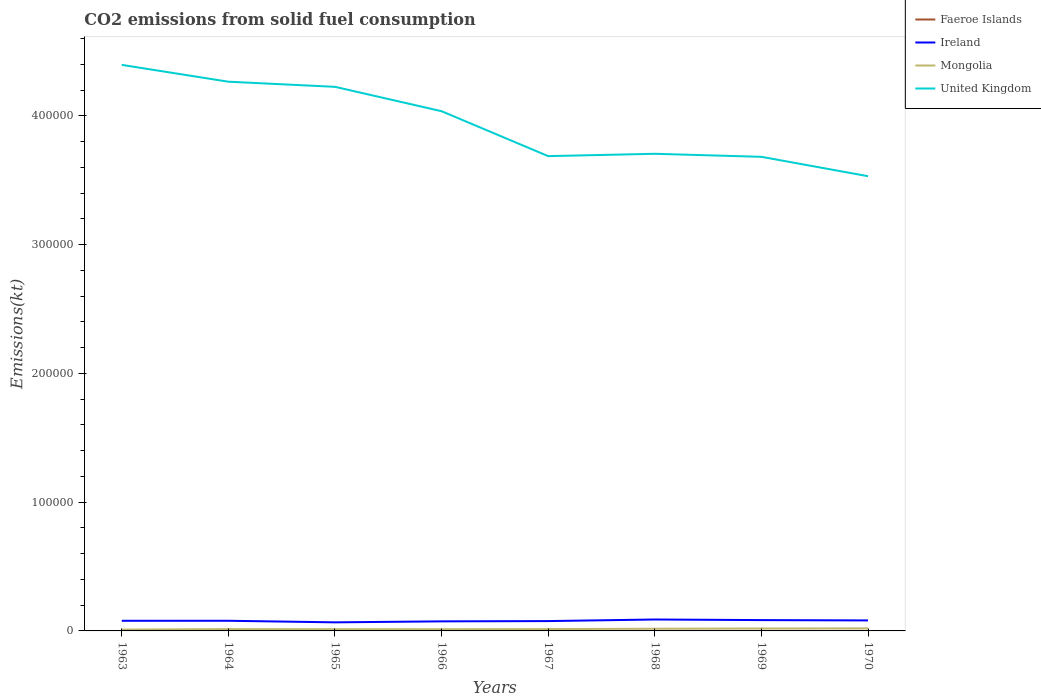Does the line corresponding to Faeroe Islands intersect with the line corresponding to Ireland?
Give a very brief answer. No. Is the number of lines equal to the number of legend labels?
Ensure brevity in your answer.  Yes. Across all years, what is the maximum amount of CO2 emitted in United Kingdom?
Your answer should be very brief. 3.53e+05. What is the total amount of CO2 emitted in United Kingdom in the graph?
Give a very brief answer. 5.20e+04. What is the difference between the highest and the second highest amount of CO2 emitted in Mongolia?
Provide a succinct answer. 953.42. Is the amount of CO2 emitted in Ireland strictly greater than the amount of CO2 emitted in Mongolia over the years?
Your answer should be compact. No. How many lines are there?
Offer a very short reply. 4. How many years are there in the graph?
Your answer should be compact. 8. What is the difference between two consecutive major ticks on the Y-axis?
Keep it short and to the point. 1.00e+05. Does the graph contain grids?
Keep it short and to the point. No. Where does the legend appear in the graph?
Offer a very short reply. Top right. How are the legend labels stacked?
Provide a succinct answer. Vertical. What is the title of the graph?
Give a very brief answer. CO2 emissions from solid fuel consumption. What is the label or title of the Y-axis?
Give a very brief answer. Emissions(kt). What is the Emissions(kt) of Faeroe Islands in 1963?
Ensure brevity in your answer.  11. What is the Emissions(kt) of Ireland in 1963?
Your answer should be compact. 7880.38. What is the Emissions(kt) of Mongolia in 1963?
Give a very brief answer. 1026.76. What is the Emissions(kt) of United Kingdom in 1963?
Your answer should be compact. 4.40e+05. What is the Emissions(kt) in Faeroe Islands in 1964?
Your response must be concise. 7.33. What is the Emissions(kt) of Ireland in 1964?
Provide a succinct answer. 7887.72. What is the Emissions(kt) in Mongolia in 1964?
Provide a succinct answer. 1411.8. What is the Emissions(kt) of United Kingdom in 1964?
Keep it short and to the point. 4.27e+05. What is the Emissions(kt) in Faeroe Islands in 1965?
Your answer should be very brief. 7.33. What is the Emissions(kt) of Ireland in 1965?
Make the answer very short. 6666.61. What is the Emissions(kt) in Mongolia in 1965?
Provide a short and direct response. 1342.12. What is the Emissions(kt) in United Kingdom in 1965?
Offer a very short reply. 4.23e+05. What is the Emissions(kt) in Faeroe Islands in 1966?
Provide a succinct answer. 7.33. What is the Emissions(kt) of Ireland in 1966?
Ensure brevity in your answer.  7425.68. What is the Emissions(kt) in Mongolia in 1966?
Make the answer very short. 1338.45. What is the Emissions(kt) of United Kingdom in 1966?
Offer a terse response. 4.04e+05. What is the Emissions(kt) in Faeroe Islands in 1967?
Offer a very short reply. 3.67. What is the Emissions(kt) of Ireland in 1967?
Make the answer very short. 7649.36. What is the Emissions(kt) of Mongolia in 1967?
Give a very brief answer. 1437.46. What is the Emissions(kt) of United Kingdom in 1967?
Keep it short and to the point. 3.69e+05. What is the Emissions(kt) of Faeroe Islands in 1968?
Give a very brief answer. 3.67. What is the Emissions(kt) in Ireland in 1968?
Provide a short and direct response. 8870.47. What is the Emissions(kt) in Mongolia in 1968?
Ensure brevity in your answer.  1701.49. What is the Emissions(kt) of United Kingdom in 1968?
Keep it short and to the point. 3.71e+05. What is the Emissions(kt) of Faeroe Islands in 1969?
Offer a very short reply. 3.67. What is the Emissions(kt) of Ireland in 1969?
Your answer should be very brief. 8412.1. What is the Emissions(kt) in Mongolia in 1969?
Give a very brief answer. 1877.5. What is the Emissions(kt) of United Kingdom in 1969?
Your answer should be very brief. 3.68e+05. What is the Emissions(kt) in Faeroe Islands in 1970?
Make the answer very short. 3.67. What is the Emissions(kt) in Ireland in 1970?
Offer a very short reply. 8155.41. What is the Emissions(kt) in Mongolia in 1970?
Your response must be concise. 1980.18. What is the Emissions(kt) of United Kingdom in 1970?
Offer a terse response. 3.53e+05. Across all years, what is the maximum Emissions(kt) of Faeroe Islands?
Offer a terse response. 11. Across all years, what is the maximum Emissions(kt) of Ireland?
Keep it short and to the point. 8870.47. Across all years, what is the maximum Emissions(kt) of Mongolia?
Your answer should be compact. 1980.18. Across all years, what is the maximum Emissions(kt) of United Kingdom?
Your response must be concise. 4.40e+05. Across all years, what is the minimum Emissions(kt) of Faeroe Islands?
Offer a very short reply. 3.67. Across all years, what is the minimum Emissions(kt) in Ireland?
Your answer should be compact. 6666.61. Across all years, what is the minimum Emissions(kt) of Mongolia?
Offer a very short reply. 1026.76. Across all years, what is the minimum Emissions(kt) in United Kingdom?
Give a very brief answer. 3.53e+05. What is the total Emissions(kt) in Faeroe Islands in the graph?
Provide a short and direct response. 47.67. What is the total Emissions(kt) in Ireland in the graph?
Make the answer very short. 6.29e+04. What is the total Emissions(kt) of Mongolia in the graph?
Your response must be concise. 1.21e+04. What is the total Emissions(kt) of United Kingdom in the graph?
Make the answer very short. 3.15e+06. What is the difference between the Emissions(kt) in Faeroe Islands in 1963 and that in 1964?
Give a very brief answer. 3.67. What is the difference between the Emissions(kt) of Ireland in 1963 and that in 1964?
Provide a succinct answer. -7.33. What is the difference between the Emissions(kt) in Mongolia in 1963 and that in 1964?
Keep it short and to the point. -385.04. What is the difference between the Emissions(kt) in United Kingdom in 1963 and that in 1964?
Your answer should be compact. 1.31e+04. What is the difference between the Emissions(kt) of Faeroe Islands in 1963 and that in 1965?
Make the answer very short. 3.67. What is the difference between the Emissions(kt) of Ireland in 1963 and that in 1965?
Keep it short and to the point. 1213.78. What is the difference between the Emissions(kt) in Mongolia in 1963 and that in 1965?
Ensure brevity in your answer.  -315.36. What is the difference between the Emissions(kt) of United Kingdom in 1963 and that in 1965?
Your answer should be very brief. 1.70e+04. What is the difference between the Emissions(kt) in Faeroe Islands in 1963 and that in 1966?
Your answer should be very brief. 3.67. What is the difference between the Emissions(kt) of Ireland in 1963 and that in 1966?
Provide a short and direct response. 454.71. What is the difference between the Emissions(kt) of Mongolia in 1963 and that in 1966?
Ensure brevity in your answer.  -311.69. What is the difference between the Emissions(kt) of United Kingdom in 1963 and that in 1966?
Provide a short and direct response. 3.60e+04. What is the difference between the Emissions(kt) in Faeroe Islands in 1963 and that in 1967?
Provide a short and direct response. 7.33. What is the difference between the Emissions(kt) of Ireland in 1963 and that in 1967?
Offer a terse response. 231.02. What is the difference between the Emissions(kt) in Mongolia in 1963 and that in 1967?
Offer a very short reply. -410.7. What is the difference between the Emissions(kt) in United Kingdom in 1963 and that in 1967?
Give a very brief answer. 7.09e+04. What is the difference between the Emissions(kt) of Faeroe Islands in 1963 and that in 1968?
Make the answer very short. 7.33. What is the difference between the Emissions(kt) in Ireland in 1963 and that in 1968?
Make the answer very short. -990.09. What is the difference between the Emissions(kt) in Mongolia in 1963 and that in 1968?
Your response must be concise. -674.73. What is the difference between the Emissions(kt) of United Kingdom in 1963 and that in 1968?
Your answer should be very brief. 6.91e+04. What is the difference between the Emissions(kt) of Faeroe Islands in 1963 and that in 1969?
Provide a succinct answer. 7.33. What is the difference between the Emissions(kt) of Ireland in 1963 and that in 1969?
Make the answer very short. -531.72. What is the difference between the Emissions(kt) in Mongolia in 1963 and that in 1969?
Offer a terse response. -850.74. What is the difference between the Emissions(kt) of United Kingdom in 1963 and that in 1969?
Offer a terse response. 7.14e+04. What is the difference between the Emissions(kt) in Faeroe Islands in 1963 and that in 1970?
Your answer should be compact. 7.33. What is the difference between the Emissions(kt) of Ireland in 1963 and that in 1970?
Offer a terse response. -275.02. What is the difference between the Emissions(kt) of Mongolia in 1963 and that in 1970?
Provide a succinct answer. -953.42. What is the difference between the Emissions(kt) of United Kingdom in 1963 and that in 1970?
Your response must be concise. 8.65e+04. What is the difference between the Emissions(kt) of Faeroe Islands in 1964 and that in 1965?
Offer a very short reply. 0. What is the difference between the Emissions(kt) of Ireland in 1964 and that in 1965?
Offer a terse response. 1221.11. What is the difference between the Emissions(kt) of Mongolia in 1964 and that in 1965?
Give a very brief answer. 69.67. What is the difference between the Emissions(kt) in United Kingdom in 1964 and that in 1965?
Your answer should be compact. 3975.03. What is the difference between the Emissions(kt) in Ireland in 1964 and that in 1966?
Keep it short and to the point. 462.04. What is the difference between the Emissions(kt) of Mongolia in 1964 and that in 1966?
Offer a very short reply. 73.34. What is the difference between the Emissions(kt) in United Kingdom in 1964 and that in 1966?
Make the answer very short. 2.29e+04. What is the difference between the Emissions(kt) of Faeroe Islands in 1964 and that in 1967?
Offer a terse response. 3.67. What is the difference between the Emissions(kt) of Ireland in 1964 and that in 1967?
Make the answer very short. 238.35. What is the difference between the Emissions(kt) of Mongolia in 1964 and that in 1967?
Your answer should be very brief. -25.67. What is the difference between the Emissions(kt) of United Kingdom in 1964 and that in 1967?
Give a very brief answer. 5.78e+04. What is the difference between the Emissions(kt) of Faeroe Islands in 1964 and that in 1968?
Offer a very short reply. 3.67. What is the difference between the Emissions(kt) of Ireland in 1964 and that in 1968?
Provide a succinct answer. -982.76. What is the difference between the Emissions(kt) of Mongolia in 1964 and that in 1968?
Provide a succinct answer. -289.69. What is the difference between the Emissions(kt) in United Kingdom in 1964 and that in 1968?
Your response must be concise. 5.60e+04. What is the difference between the Emissions(kt) of Faeroe Islands in 1964 and that in 1969?
Your answer should be very brief. 3.67. What is the difference between the Emissions(kt) of Ireland in 1964 and that in 1969?
Give a very brief answer. -524.38. What is the difference between the Emissions(kt) of Mongolia in 1964 and that in 1969?
Offer a very short reply. -465.71. What is the difference between the Emissions(kt) of United Kingdom in 1964 and that in 1969?
Provide a short and direct response. 5.83e+04. What is the difference between the Emissions(kt) of Faeroe Islands in 1964 and that in 1970?
Provide a short and direct response. 3.67. What is the difference between the Emissions(kt) of Ireland in 1964 and that in 1970?
Offer a very short reply. -267.69. What is the difference between the Emissions(kt) in Mongolia in 1964 and that in 1970?
Ensure brevity in your answer.  -568.38. What is the difference between the Emissions(kt) in United Kingdom in 1964 and that in 1970?
Make the answer very short. 7.34e+04. What is the difference between the Emissions(kt) in Ireland in 1965 and that in 1966?
Provide a short and direct response. -759.07. What is the difference between the Emissions(kt) in Mongolia in 1965 and that in 1966?
Offer a very short reply. 3.67. What is the difference between the Emissions(kt) in United Kingdom in 1965 and that in 1966?
Ensure brevity in your answer.  1.89e+04. What is the difference between the Emissions(kt) in Faeroe Islands in 1965 and that in 1967?
Offer a terse response. 3.67. What is the difference between the Emissions(kt) in Ireland in 1965 and that in 1967?
Offer a terse response. -982.76. What is the difference between the Emissions(kt) of Mongolia in 1965 and that in 1967?
Your answer should be very brief. -95.34. What is the difference between the Emissions(kt) in United Kingdom in 1965 and that in 1967?
Your response must be concise. 5.38e+04. What is the difference between the Emissions(kt) in Faeroe Islands in 1965 and that in 1968?
Ensure brevity in your answer.  3.67. What is the difference between the Emissions(kt) in Ireland in 1965 and that in 1968?
Offer a terse response. -2203.87. What is the difference between the Emissions(kt) in Mongolia in 1965 and that in 1968?
Offer a terse response. -359.37. What is the difference between the Emissions(kt) in United Kingdom in 1965 and that in 1968?
Keep it short and to the point. 5.20e+04. What is the difference between the Emissions(kt) of Faeroe Islands in 1965 and that in 1969?
Provide a succinct answer. 3.67. What is the difference between the Emissions(kt) in Ireland in 1965 and that in 1969?
Make the answer very short. -1745.49. What is the difference between the Emissions(kt) of Mongolia in 1965 and that in 1969?
Your response must be concise. -535.38. What is the difference between the Emissions(kt) in United Kingdom in 1965 and that in 1969?
Offer a very short reply. 5.44e+04. What is the difference between the Emissions(kt) in Faeroe Islands in 1965 and that in 1970?
Keep it short and to the point. 3.67. What is the difference between the Emissions(kt) in Ireland in 1965 and that in 1970?
Your answer should be compact. -1488.8. What is the difference between the Emissions(kt) in Mongolia in 1965 and that in 1970?
Provide a succinct answer. -638.06. What is the difference between the Emissions(kt) in United Kingdom in 1965 and that in 1970?
Make the answer very short. 6.94e+04. What is the difference between the Emissions(kt) in Faeroe Islands in 1966 and that in 1967?
Keep it short and to the point. 3.67. What is the difference between the Emissions(kt) of Ireland in 1966 and that in 1967?
Your answer should be compact. -223.69. What is the difference between the Emissions(kt) in Mongolia in 1966 and that in 1967?
Make the answer very short. -99.01. What is the difference between the Emissions(kt) of United Kingdom in 1966 and that in 1967?
Your answer should be very brief. 3.49e+04. What is the difference between the Emissions(kt) of Faeroe Islands in 1966 and that in 1968?
Offer a very short reply. 3.67. What is the difference between the Emissions(kt) of Ireland in 1966 and that in 1968?
Offer a very short reply. -1444.8. What is the difference between the Emissions(kt) of Mongolia in 1966 and that in 1968?
Give a very brief answer. -363.03. What is the difference between the Emissions(kt) of United Kingdom in 1966 and that in 1968?
Your response must be concise. 3.31e+04. What is the difference between the Emissions(kt) of Faeroe Islands in 1966 and that in 1969?
Make the answer very short. 3.67. What is the difference between the Emissions(kt) in Ireland in 1966 and that in 1969?
Offer a terse response. -986.42. What is the difference between the Emissions(kt) in Mongolia in 1966 and that in 1969?
Make the answer very short. -539.05. What is the difference between the Emissions(kt) of United Kingdom in 1966 and that in 1969?
Provide a succinct answer. 3.54e+04. What is the difference between the Emissions(kt) in Faeroe Islands in 1966 and that in 1970?
Ensure brevity in your answer.  3.67. What is the difference between the Emissions(kt) of Ireland in 1966 and that in 1970?
Give a very brief answer. -729.73. What is the difference between the Emissions(kt) in Mongolia in 1966 and that in 1970?
Make the answer very short. -641.73. What is the difference between the Emissions(kt) in United Kingdom in 1966 and that in 1970?
Offer a terse response. 5.05e+04. What is the difference between the Emissions(kt) in Ireland in 1967 and that in 1968?
Your answer should be compact. -1221.11. What is the difference between the Emissions(kt) of Mongolia in 1967 and that in 1968?
Ensure brevity in your answer.  -264.02. What is the difference between the Emissions(kt) in United Kingdom in 1967 and that in 1968?
Offer a very short reply. -1818.83. What is the difference between the Emissions(kt) in Ireland in 1967 and that in 1969?
Provide a succinct answer. -762.74. What is the difference between the Emissions(kt) of Mongolia in 1967 and that in 1969?
Make the answer very short. -440.04. What is the difference between the Emissions(kt) in United Kingdom in 1967 and that in 1969?
Keep it short and to the point. 535.38. What is the difference between the Emissions(kt) in Ireland in 1967 and that in 1970?
Your answer should be compact. -506.05. What is the difference between the Emissions(kt) in Mongolia in 1967 and that in 1970?
Your response must be concise. -542.72. What is the difference between the Emissions(kt) in United Kingdom in 1967 and that in 1970?
Give a very brief answer. 1.56e+04. What is the difference between the Emissions(kt) of Faeroe Islands in 1968 and that in 1969?
Make the answer very short. 0. What is the difference between the Emissions(kt) of Ireland in 1968 and that in 1969?
Keep it short and to the point. 458.38. What is the difference between the Emissions(kt) of Mongolia in 1968 and that in 1969?
Make the answer very short. -176.02. What is the difference between the Emissions(kt) in United Kingdom in 1968 and that in 1969?
Offer a terse response. 2354.21. What is the difference between the Emissions(kt) in Faeroe Islands in 1968 and that in 1970?
Give a very brief answer. 0. What is the difference between the Emissions(kt) of Ireland in 1968 and that in 1970?
Make the answer very short. 715.07. What is the difference between the Emissions(kt) of Mongolia in 1968 and that in 1970?
Ensure brevity in your answer.  -278.69. What is the difference between the Emissions(kt) in United Kingdom in 1968 and that in 1970?
Your answer should be very brief. 1.74e+04. What is the difference between the Emissions(kt) of Faeroe Islands in 1969 and that in 1970?
Your answer should be very brief. 0. What is the difference between the Emissions(kt) in Ireland in 1969 and that in 1970?
Offer a very short reply. 256.69. What is the difference between the Emissions(kt) of Mongolia in 1969 and that in 1970?
Ensure brevity in your answer.  -102.68. What is the difference between the Emissions(kt) in United Kingdom in 1969 and that in 1970?
Give a very brief answer. 1.51e+04. What is the difference between the Emissions(kt) in Faeroe Islands in 1963 and the Emissions(kt) in Ireland in 1964?
Make the answer very short. -7876.72. What is the difference between the Emissions(kt) of Faeroe Islands in 1963 and the Emissions(kt) of Mongolia in 1964?
Make the answer very short. -1400.79. What is the difference between the Emissions(kt) in Faeroe Islands in 1963 and the Emissions(kt) in United Kingdom in 1964?
Ensure brevity in your answer.  -4.27e+05. What is the difference between the Emissions(kt) in Ireland in 1963 and the Emissions(kt) in Mongolia in 1964?
Your answer should be compact. 6468.59. What is the difference between the Emissions(kt) in Ireland in 1963 and the Emissions(kt) in United Kingdom in 1964?
Provide a short and direct response. -4.19e+05. What is the difference between the Emissions(kt) in Mongolia in 1963 and the Emissions(kt) in United Kingdom in 1964?
Your answer should be very brief. -4.26e+05. What is the difference between the Emissions(kt) of Faeroe Islands in 1963 and the Emissions(kt) of Ireland in 1965?
Offer a very short reply. -6655.6. What is the difference between the Emissions(kt) in Faeroe Islands in 1963 and the Emissions(kt) in Mongolia in 1965?
Your response must be concise. -1331.12. What is the difference between the Emissions(kt) in Faeroe Islands in 1963 and the Emissions(kt) in United Kingdom in 1965?
Make the answer very short. -4.23e+05. What is the difference between the Emissions(kt) in Ireland in 1963 and the Emissions(kt) in Mongolia in 1965?
Offer a terse response. 6538.26. What is the difference between the Emissions(kt) in Ireland in 1963 and the Emissions(kt) in United Kingdom in 1965?
Keep it short and to the point. -4.15e+05. What is the difference between the Emissions(kt) of Mongolia in 1963 and the Emissions(kt) of United Kingdom in 1965?
Offer a terse response. -4.22e+05. What is the difference between the Emissions(kt) of Faeroe Islands in 1963 and the Emissions(kt) of Ireland in 1966?
Keep it short and to the point. -7414.67. What is the difference between the Emissions(kt) of Faeroe Islands in 1963 and the Emissions(kt) of Mongolia in 1966?
Make the answer very short. -1327.45. What is the difference between the Emissions(kt) of Faeroe Islands in 1963 and the Emissions(kt) of United Kingdom in 1966?
Give a very brief answer. -4.04e+05. What is the difference between the Emissions(kt) in Ireland in 1963 and the Emissions(kt) in Mongolia in 1966?
Offer a very short reply. 6541.93. What is the difference between the Emissions(kt) in Ireland in 1963 and the Emissions(kt) in United Kingdom in 1966?
Offer a very short reply. -3.96e+05. What is the difference between the Emissions(kt) in Mongolia in 1963 and the Emissions(kt) in United Kingdom in 1966?
Your answer should be compact. -4.03e+05. What is the difference between the Emissions(kt) in Faeroe Islands in 1963 and the Emissions(kt) in Ireland in 1967?
Ensure brevity in your answer.  -7638.36. What is the difference between the Emissions(kt) of Faeroe Islands in 1963 and the Emissions(kt) of Mongolia in 1967?
Your answer should be very brief. -1426.46. What is the difference between the Emissions(kt) in Faeroe Islands in 1963 and the Emissions(kt) in United Kingdom in 1967?
Provide a succinct answer. -3.69e+05. What is the difference between the Emissions(kt) of Ireland in 1963 and the Emissions(kt) of Mongolia in 1967?
Offer a terse response. 6442.92. What is the difference between the Emissions(kt) in Ireland in 1963 and the Emissions(kt) in United Kingdom in 1967?
Ensure brevity in your answer.  -3.61e+05. What is the difference between the Emissions(kt) in Mongolia in 1963 and the Emissions(kt) in United Kingdom in 1967?
Your answer should be compact. -3.68e+05. What is the difference between the Emissions(kt) in Faeroe Islands in 1963 and the Emissions(kt) in Ireland in 1968?
Keep it short and to the point. -8859.47. What is the difference between the Emissions(kt) of Faeroe Islands in 1963 and the Emissions(kt) of Mongolia in 1968?
Ensure brevity in your answer.  -1690.49. What is the difference between the Emissions(kt) of Faeroe Islands in 1963 and the Emissions(kt) of United Kingdom in 1968?
Give a very brief answer. -3.71e+05. What is the difference between the Emissions(kt) of Ireland in 1963 and the Emissions(kt) of Mongolia in 1968?
Your answer should be very brief. 6178.9. What is the difference between the Emissions(kt) in Ireland in 1963 and the Emissions(kt) in United Kingdom in 1968?
Your answer should be very brief. -3.63e+05. What is the difference between the Emissions(kt) of Mongolia in 1963 and the Emissions(kt) of United Kingdom in 1968?
Keep it short and to the point. -3.70e+05. What is the difference between the Emissions(kt) of Faeroe Islands in 1963 and the Emissions(kt) of Ireland in 1969?
Offer a very short reply. -8401.1. What is the difference between the Emissions(kt) in Faeroe Islands in 1963 and the Emissions(kt) in Mongolia in 1969?
Ensure brevity in your answer.  -1866.5. What is the difference between the Emissions(kt) of Faeroe Islands in 1963 and the Emissions(kt) of United Kingdom in 1969?
Provide a succinct answer. -3.68e+05. What is the difference between the Emissions(kt) of Ireland in 1963 and the Emissions(kt) of Mongolia in 1969?
Your answer should be very brief. 6002.88. What is the difference between the Emissions(kt) of Ireland in 1963 and the Emissions(kt) of United Kingdom in 1969?
Offer a very short reply. -3.60e+05. What is the difference between the Emissions(kt) of Mongolia in 1963 and the Emissions(kt) of United Kingdom in 1969?
Make the answer very short. -3.67e+05. What is the difference between the Emissions(kt) of Faeroe Islands in 1963 and the Emissions(kt) of Ireland in 1970?
Your response must be concise. -8144.41. What is the difference between the Emissions(kt) of Faeroe Islands in 1963 and the Emissions(kt) of Mongolia in 1970?
Your answer should be very brief. -1969.18. What is the difference between the Emissions(kt) of Faeroe Islands in 1963 and the Emissions(kt) of United Kingdom in 1970?
Your answer should be compact. -3.53e+05. What is the difference between the Emissions(kt) of Ireland in 1963 and the Emissions(kt) of Mongolia in 1970?
Ensure brevity in your answer.  5900.2. What is the difference between the Emissions(kt) of Ireland in 1963 and the Emissions(kt) of United Kingdom in 1970?
Your answer should be compact. -3.45e+05. What is the difference between the Emissions(kt) in Mongolia in 1963 and the Emissions(kt) in United Kingdom in 1970?
Give a very brief answer. -3.52e+05. What is the difference between the Emissions(kt) of Faeroe Islands in 1964 and the Emissions(kt) of Ireland in 1965?
Your response must be concise. -6659.27. What is the difference between the Emissions(kt) of Faeroe Islands in 1964 and the Emissions(kt) of Mongolia in 1965?
Make the answer very short. -1334.79. What is the difference between the Emissions(kt) of Faeroe Islands in 1964 and the Emissions(kt) of United Kingdom in 1965?
Offer a terse response. -4.23e+05. What is the difference between the Emissions(kt) of Ireland in 1964 and the Emissions(kt) of Mongolia in 1965?
Your answer should be very brief. 6545.6. What is the difference between the Emissions(kt) in Ireland in 1964 and the Emissions(kt) in United Kingdom in 1965?
Give a very brief answer. -4.15e+05. What is the difference between the Emissions(kt) in Mongolia in 1964 and the Emissions(kt) in United Kingdom in 1965?
Make the answer very short. -4.21e+05. What is the difference between the Emissions(kt) of Faeroe Islands in 1964 and the Emissions(kt) of Ireland in 1966?
Give a very brief answer. -7418.34. What is the difference between the Emissions(kt) in Faeroe Islands in 1964 and the Emissions(kt) in Mongolia in 1966?
Make the answer very short. -1331.12. What is the difference between the Emissions(kt) in Faeroe Islands in 1964 and the Emissions(kt) in United Kingdom in 1966?
Give a very brief answer. -4.04e+05. What is the difference between the Emissions(kt) in Ireland in 1964 and the Emissions(kt) in Mongolia in 1966?
Offer a very short reply. 6549.26. What is the difference between the Emissions(kt) of Ireland in 1964 and the Emissions(kt) of United Kingdom in 1966?
Offer a very short reply. -3.96e+05. What is the difference between the Emissions(kt) of Mongolia in 1964 and the Emissions(kt) of United Kingdom in 1966?
Make the answer very short. -4.02e+05. What is the difference between the Emissions(kt) of Faeroe Islands in 1964 and the Emissions(kt) of Ireland in 1967?
Give a very brief answer. -7642.03. What is the difference between the Emissions(kt) of Faeroe Islands in 1964 and the Emissions(kt) of Mongolia in 1967?
Offer a very short reply. -1430.13. What is the difference between the Emissions(kt) of Faeroe Islands in 1964 and the Emissions(kt) of United Kingdom in 1967?
Your answer should be compact. -3.69e+05. What is the difference between the Emissions(kt) of Ireland in 1964 and the Emissions(kt) of Mongolia in 1967?
Your response must be concise. 6450.25. What is the difference between the Emissions(kt) in Ireland in 1964 and the Emissions(kt) in United Kingdom in 1967?
Keep it short and to the point. -3.61e+05. What is the difference between the Emissions(kt) of Mongolia in 1964 and the Emissions(kt) of United Kingdom in 1967?
Provide a short and direct response. -3.67e+05. What is the difference between the Emissions(kt) of Faeroe Islands in 1964 and the Emissions(kt) of Ireland in 1968?
Your response must be concise. -8863.14. What is the difference between the Emissions(kt) in Faeroe Islands in 1964 and the Emissions(kt) in Mongolia in 1968?
Your response must be concise. -1694.15. What is the difference between the Emissions(kt) in Faeroe Islands in 1964 and the Emissions(kt) in United Kingdom in 1968?
Ensure brevity in your answer.  -3.71e+05. What is the difference between the Emissions(kt) in Ireland in 1964 and the Emissions(kt) in Mongolia in 1968?
Your answer should be compact. 6186.23. What is the difference between the Emissions(kt) of Ireland in 1964 and the Emissions(kt) of United Kingdom in 1968?
Offer a terse response. -3.63e+05. What is the difference between the Emissions(kt) of Mongolia in 1964 and the Emissions(kt) of United Kingdom in 1968?
Your response must be concise. -3.69e+05. What is the difference between the Emissions(kt) in Faeroe Islands in 1964 and the Emissions(kt) in Ireland in 1969?
Ensure brevity in your answer.  -8404.76. What is the difference between the Emissions(kt) of Faeroe Islands in 1964 and the Emissions(kt) of Mongolia in 1969?
Give a very brief answer. -1870.17. What is the difference between the Emissions(kt) of Faeroe Islands in 1964 and the Emissions(kt) of United Kingdom in 1969?
Your answer should be compact. -3.68e+05. What is the difference between the Emissions(kt) in Ireland in 1964 and the Emissions(kt) in Mongolia in 1969?
Your answer should be compact. 6010.21. What is the difference between the Emissions(kt) of Ireland in 1964 and the Emissions(kt) of United Kingdom in 1969?
Your answer should be compact. -3.60e+05. What is the difference between the Emissions(kt) in Mongolia in 1964 and the Emissions(kt) in United Kingdom in 1969?
Give a very brief answer. -3.67e+05. What is the difference between the Emissions(kt) in Faeroe Islands in 1964 and the Emissions(kt) in Ireland in 1970?
Ensure brevity in your answer.  -8148.07. What is the difference between the Emissions(kt) of Faeroe Islands in 1964 and the Emissions(kt) of Mongolia in 1970?
Offer a terse response. -1972.85. What is the difference between the Emissions(kt) in Faeroe Islands in 1964 and the Emissions(kt) in United Kingdom in 1970?
Your response must be concise. -3.53e+05. What is the difference between the Emissions(kt) of Ireland in 1964 and the Emissions(kt) of Mongolia in 1970?
Make the answer very short. 5907.54. What is the difference between the Emissions(kt) of Ireland in 1964 and the Emissions(kt) of United Kingdom in 1970?
Your answer should be compact. -3.45e+05. What is the difference between the Emissions(kt) in Mongolia in 1964 and the Emissions(kt) in United Kingdom in 1970?
Make the answer very short. -3.52e+05. What is the difference between the Emissions(kt) in Faeroe Islands in 1965 and the Emissions(kt) in Ireland in 1966?
Offer a terse response. -7418.34. What is the difference between the Emissions(kt) of Faeroe Islands in 1965 and the Emissions(kt) of Mongolia in 1966?
Provide a short and direct response. -1331.12. What is the difference between the Emissions(kt) in Faeroe Islands in 1965 and the Emissions(kt) in United Kingdom in 1966?
Ensure brevity in your answer.  -4.04e+05. What is the difference between the Emissions(kt) in Ireland in 1965 and the Emissions(kt) in Mongolia in 1966?
Your answer should be compact. 5328.15. What is the difference between the Emissions(kt) of Ireland in 1965 and the Emissions(kt) of United Kingdom in 1966?
Offer a very short reply. -3.97e+05. What is the difference between the Emissions(kt) of Mongolia in 1965 and the Emissions(kt) of United Kingdom in 1966?
Offer a very short reply. -4.02e+05. What is the difference between the Emissions(kt) in Faeroe Islands in 1965 and the Emissions(kt) in Ireland in 1967?
Provide a short and direct response. -7642.03. What is the difference between the Emissions(kt) of Faeroe Islands in 1965 and the Emissions(kt) of Mongolia in 1967?
Make the answer very short. -1430.13. What is the difference between the Emissions(kt) of Faeroe Islands in 1965 and the Emissions(kt) of United Kingdom in 1967?
Give a very brief answer. -3.69e+05. What is the difference between the Emissions(kt) of Ireland in 1965 and the Emissions(kt) of Mongolia in 1967?
Give a very brief answer. 5229.14. What is the difference between the Emissions(kt) in Ireland in 1965 and the Emissions(kt) in United Kingdom in 1967?
Provide a succinct answer. -3.62e+05. What is the difference between the Emissions(kt) in Mongolia in 1965 and the Emissions(kt) in United Kingdom in 1967?
Ensure brevity in your answer.  -3.67e+05. What is the difference between the Emissions(kt) in Faeroe Islands in 1965 and the Emissions(kt) in Ireland in 1968?
Provide a succinct answer. -8863.14. What is the difference between the Emissions(kt) in Faeroe Islands in 1965 and the Emissions(kt) in Mongolia in 1968?
Your answer should be compact. -1694.15. What is the difference between the Emissions(kt) in Faeroe Islands in 1965 and the Emissions(kt) in United Kingdom in 1968?
Make the answer very short. -3.71e+05. What is the difference between the Emissions(kt) of Ireland in 1965 and the Emissions(kt) of Mongolia in 1968?
Give a very brief answer. 4965.12. What is the difference between the Emissions(kt) in Ireland in 1965 and the Emissions(kt) in United Kingdom in 1968?
Offer a very short reply. -3.64e+05. What is the difference between the Emissions(kt) in Mongolia in 1965 and the Emissions(kt) in United Kingdom in 1968?
Offer a terse response. -3.69e+05. What is the difference between the Emissions(kt) of Faeroe Islands in 1965 and the Emissions(kt) of Ireland in 1969?
Make the answer very short. -8404.76. What is the difference between the Emissions(kt) of Faeroe Islands in 1965 and the Emissions(kt) of Mongolia in 1969?
Your answer should be compact. -1870.17. What is the difference between the Emissions(kt) of Faeroe Islands in 1965 and the Emissions(kt) of United Kingdom in 1969?
Ensure brevity in your answer.  -3.68e+05. What is the difference between the Emissions(kt) in Ireland in 1965 and the Emissions(kt) in Mongolia in 1969?
Give a very brief answer. 4789.1. What is the difference between the Emissions(kt) in Ireland in 1965 and the Emissions(kt) in United Kingdom in 1969?
Make the answer very short. -3.62e+05. What is the difference between the Emissions(kt) in Mongolia in 1965 and the Emissions(kt) in United Kingdom in 1969?
Give a very brief answer. -3.67e+05. What is the difference between the Emissions(kt) in Faeroe Islands in 1965 and the Emissions(kt) in Ireland in 1970?
Provide a succinct answer. -8148.07. What is the difference between the Emissions(kt) of Faeroe Islands in 1965 and the Emissions(kt) of Mongolia in 1970?
Your response must be concise. -1972.85. What is the difference between the Emissions(kt) of Faeroe Islands in 1965 and the Emissions(kt) of United Kingdom in 1970?
Make the answer very short. -3.53e+05. What is the difference between the Emissions(kt) of Ireland in 1965 and the Emissions(kt) of Mongolia in 1970?
Provide a succinct answer. 4686.43. What is the difference between the Emissions(kt) of Ireland in 1965 and the Emissions(kt) of United Kingdom in 1970?
Make the answer very short. -3.47e+05. What is the difference between the Emissions(kt) in Mongolia in 1965 and the Emissions(kt) in United Kingdom in 1970?
Make the answer very short. -3.52e+05. What is the difference between the Emissions(kt) in Faeroe Islands in 1966 and the Emissions(kt) in Ireland in 1967?
Keep it short and to the point. -7642.03. What is the difference between the Emissions(kt) of Faeroe Islands in 1966 and the Emissions(kt) of Mongolia in 1967?
Provide a short and direct response. -1430.13. What is the difference between the Emissions(kt) in Faeroe Islands in 1966 and the Emissions(kt) in United Kingdom in 1967?
Ensure brevity in your answer.  -3.69e+05. What is the difference between the Emissions(kt) of Ireland in 1966 and the Emissions(kt) of Mongolia in 1967?
Provide a succinct answer. 5988.21. What is the difference between the Emissions(kt) in Ireland in 1966 and the Emissions(kt) in United Kingdom in 1967?
Your answer should be very brief. -3.61e+05. What is the difference between the Emissions(kt) in Mongolia in 1966 and the Emissions(kt) in United Kingdom in 1967?
Your answer should be compact. -3.67e+05. What is the difference between the Emissions(kt) in Faeroe Islands in 1966 and the Emissions(kt) in Ireland in 1968?
Offer a terse response. -8863.14. What is the difference between the Emissions(kt) of Faeroe Islands in 1966 and the Emissions(kt) of Mongolia in 1968?
Your response must be concise. -1694.15. What is the difference between the Emissions(kt) in Faeroe Islands in 1966 and the Emissions(kt) in United Kingdom in 1968?
Give a very brief answer. -3.71e+05. What is the difference between the Emissions(kt) of Ireland in 1966 and the Emissions(kt) of Mongolia in 1968?
Offer a terse response. 5724.19. What is the difference between the Emissions(kt) in Ireland in 1966 and the Emissions(kt) in United Kingdom in 1968?
Provide a short and direct response. -3.63e+05. What is the difference between the Emissions(kt) of Mongolia in 1966 and the Emissions(kt) of United Kingdom in 1968?
Ensure brevity in your answer.  -3.69e+05. What is the difference between the Emissions(kt) of Faeroe Islands in 1966 and the Emissions(kt) of Ireland in 1969?
Give a very brief answer. -8404.76. What is the difference between the Emissions(kt) in Faeroe Islands in 1966 and the Emissions(kt) in Mongolia in 1969?
Provide a succinct answer. -1870.17. What is the difference between the Emissions(kt) of Faeroe Islands in 1966 and the Emissions(kt) of United Kingdom in 1969?
Ensure brevity in your answer.  -3.68e+05. What is the difference between the Emissions(kt) in Ireland in 1966 and the Emissions(kt) in Mongolia in 1969?
Offer a very short reply. 5548.17. What is the difference between the Emissions(kt) in Ireland in 1966 and the Emissions(kt) in United Kingdom in 1969?
Keep it short and to the point. -3.61e+05. What is the difference between the Emissions(kt) in Mongolia in 1966 and the Emissions(kt) in United Kingdom in 1969?
Offer a terse response. -3.67e+05. What is the difference between the Emissions(kt) in Faeroe Islands in 1966 and the Emissions(kt) in Ireland in 1970?
Offer a very short reply. -8148.07. What is the difference between the Emissions(kt) in Faeroe Islands in 1966 and the Emissions(kt) in Mongolia in 1970?
Offer a terse response. -1972.85. What is the difference between the Emissions(kt) of Faeroe Islands in 1966 and the Emissions(kt) of United Kingdom in 1970?
Offer a very short reply. -3.53e+05. What is the difference between the Emissions(kt) of Ireland in 1966 and the Emissions(kt) of Mongolia in 1970?
Your answer should be compact. 5445.49. What is the difference between the Emissions(kt) in Ireland in 1966 and the Emissions(kt) in United Kingdom in 1970?
Your response must be concise. -3.46e+05. What is the difference between the Emissions(kt) in Mongolia in 1966 and the Emissions(kt) in United Kingdom in 1970?
Give a very brief answer. -3.52e+05. What is the difference between the Emissions(kt) of Faeroe Islands in 1967 and the Emissions(kt) of Ireland in 1968?
Ensure brevity in your answer.  -8866.81. What is the difference between the Emissions(kt) of Faeroe Islands in 1967 and the Emissions(kt) of Mongolia in 1968?
Offer a very short reply. -1697.82. What is the difference between the Emissions(kt) in Faeroe Islands in 1967 and the Emissions(kt) in United Kingdom in 1968?
Keep it short and to the point. -3.71e+05. What is the difference between the Emissions(kt) of Ireland in 1967 and the Emissions(kt) of Mongolia in 1968?
Your answer should be compact. 5947.87. What is the difference between the Emissions(kt) of Ireland in 1967 and the Emissions(kt) of United Kingdom in 1968?
Provide a succinct answer. -3.63e+05. What is the difference between the Emissions(kt) of Mongolia in 1967 and the Emissions(kt) of United Kingdom in 1968?
Give a very brief answer. -3.69e+05. What is the difference between the Emissions(kt) in Faeroe Islands in 1967 and the Emissions(kt) in Ireland in 1969?
Make the answer very short. -8408.43. What is the difference between the Emissions(kt) in Faeroe Islands in 1967 and the Emissions(kt) in Mongolia in 1969?
Make the answer very short. -1873.84. What is the difference between the Emissions(kt) in Faeroe Islands in 1967 and the Emissions(kt) in United Kingdom in 1969?
Offer a terse response. -3.68e+05. What is the difference between the Emissions(kt) of Ireland in 1967 and the Emissions(kt) of Mongolia in 1969?
Make the answer very short. 5771.86. What is the difference between the Emissions(kt) of Ireland in 1967 and the Emissions(kt) of United Kingdom in 1969?
Provide a short and direct response. -3.61e+05. What is the difference between the Emissions(kt) in Mongolia in 1967 and the Emissions(kt) in United Kingdom in 1969?
Your response must be concise. -3.67e+05. What is the difference between the Emissions(kt) of Faeroe Islands in 1967 and the Emissions(kt) of Ireland in 1970?
Your response must be concise. -8151.74. What is the difference between the Emissions(kt) of Faeroe Islands in 1967 and the Emissions(kt) of Mongolia in 1970?
Make the answer very short. -1976.51. What is the difference between the Emissions(kt) in Faeroe Islands in 1967 and the Emissions(kt) in United Kingdom in 1970?
Give a very brief answer. -3.53e+05. What is the difference between the Emissions(kt) in Ireland in 1967 and the Emissions(kt) in Mongolia in 1970?
Give a very brief answer. 5669.18. What is the difference between the Emissions(kt) of Ireland in 1967 and the Emissions(kt) of United Kingdom in 1970?
Your response must be concise. -3.46e+05. What is the difference between the Emissions(kt) in Mongolia in 1967 and the Emissions(kt) in United Kingdom in 1970?
Provide a short and direct response. -3.52e+05. What is the difference between the Emissions(kt) of Faeroe Islands in 1968 and the Emissions(kt) of Ireland in 1969?
Offer a terse response. -8408.43. What is the difference between the Emissions(kt) in Faeroe Islands in 1968 and the Emissions(kt) in Mongolia in 1969?
Give a very brief answer. -1873.84. What is the difference between the Emissions(kt) in Faeroe Islands in 1968 and the Emissions(kt) in United Kingdom in 1969?
Provide a short and direct response. -3.68e+05. What is the difference between the Emissions(kt) of Ireland in 1968 and the Emissions(kt) of Mongolia in 1969?
Make the answer very short. 6992.97. What is the difference between the Emissions(kt) in Ireland in 1968 and the Emissions(kt) in United Kingdom in 1969?
Your answer should be compact. -3.59e+05. What is the difference between the Emissions(kt) in Mongolia in 1968 and the Emissions(kt) in United Kingdom in 1969?
Give a very brief answer. -3.67e+05. What is the difference between the Emissions(kt) in Faeroe Islands in 1968 and the Emissions(kt) in Ireland in 1970?
Provide a succinct answer. -8151.74. What is the difference between the Emissions(kt) in Faeroe Islands in 1968 and the Emissions(kt) in Mongolia in 1970?
Your answer should be very brief. -1976.51. What is the difference between the Emissions(kt) of Faeroe Islands in 1968 and the Emissions(kt) of United Kingdom in 1970?
Provide a short and direct response. -3.53e+05. What is the difference between the Emissions(kt) of Ireland in 1968 and the Emissions(kt) of Mongolia in 1970?
Provide a short and direct response. 6890.29. What is the difference between the Emissions(kt) in Ireland in 1968 and the Emissions(kt) in United Kingdom in 1970?
Make the answer very short. -3.44e+05. What is the difference between the Emissions(kt) in Mongolia in 1968 and the Emissions(kt) in United Kingdom in 1970?
Offer a very short reply. -3.51e+05. What is the difference between the Emissions(kt) of Faeroe Islands in 1969 and the Emissions(kt) of Ireland in 1970?
Your answer should be compact. -8151.74. What is the difference between the Emissions(kt) in Faeroe Islands in 1969 and the Emissions(kt) in Mongolia in 1970?
Ensure brevity in your answer.  -1976.51. What is the difference between the Emissions(kt) in Faeroe Islands in 1969 and the Emissions(kt) in United Kingdom in 1970?
Your answer should be compact. -3.53e+05. What is the difference between the Emissions(kt) of Ireland in 1969 and the Emissions(kt) of Mongolia in 1970?
Ensure brevity in your answer.  6431.92. What is the difference between the Emissions(kt) of Ireland in 1969 and the Emissions(kt) of United Kingdom in 1970?
Your answer should be compact. -3.45e+05. What is the difference between the Emissions(kt) in Mongolia in 1969 and the Emissions(kt) in United Kingdom in 1970?
Your answer should be compact. -3.51e+05. What is the average Emissions(kt) of Faeroe Islands per year?
Provide a short and direct response. 5.96. What is the average Emissions(kt) in Ireland per year?
Your response must be concise. 7868.47. What is the average Emissions(kt) of Mongolia per year?
Your response must be concise. 1514.47. What is the average Emissions(kt) of United Kingdom per year?
Keep it short and to the point. 3.94e+05. In the year 1963, what is the difference between the Emissions(kt) of Faeroe Islands and Emissions(kt) of Ireland?
Keep it short and to the point. -7869.38. In the year 1963, what is the difference between the Emissions(kt) in Faeroe Islands and Emissions(kt) in Mongolia?
Make the answer very short. -1015.76. In the year 1963, what is the difference between the Emissions(kt) of Faeroe Islands and Emissions(kt) of United Kingdom?
Make the answer very short. -4.40e+05. In the year 1963, what is the difference between the Emissions(kt) in Ireland and Emissions(kt) in Mongolia?
Keep it short and to the point. 6853.62. In the year 1963, what is the difference between the Emissions(kt) in Ireland and Emissions(kt) in United Kingdom?
Keep it short and to the point. -4.32e+05. In the year 1963, what is the difference between the Emissions(kt) in Mongolia and Emissions(kt) in United Kingdom?
Ensure brevity in your answer.  -4.39e+05. In the year 1964, what is the difference between the Emissions(kt) of Faeroe Islands and Emissions(kt) of Ireland?
Make the answer very short. -7880.38. In the year 1964, what is the difference between the Emissions(kt) of Faeroe Islands and Emissions(kt) of Mongolia?
Ensure brevity in your answer.  -1404.46. In the year 1964, what is the difference between the Emissions(kt) of Faeroe Islands and Emissions(kt) of United Kingdom?
Offer a very short reply. -4.27e+05. In the year 1964, what is the difference between the Emissions(kt) of Ireland and Emissions(kt) of Mongolia?
Your response must be concise. 6475.92. In the year 1964, what is the difference between the Emissions(kt) in Ireland and Emissions(kt) in United Kingdom?
Give a very brief answer. -4.19e+05. In the year 1964, what is the difference between the Emissions(kt) in Mongolia and Emissions(kt) in United Kingdom?
Offer a terse response. -4.25e+05. In the year 1965, what is the difference between the Emissions(kt) of Faeroe Islands and Emissions(kt) of Ireland?
Keep it short and to the point. -6659.27. In the year 1965, what is the difference between the Emissions(kt) of Faeroe Islands and Emissions(kt) of Mongolia?
Make the answer very short. -1334.79. In the year 1965, what is the difference between the Emissions(kt) of Faeroe Islands and Emissions(kt) of United Kingdom?
Offer a terse response. -4.23e+05. In the year 1965, what is the difference between the Emissions(kt) of Ireland and Emissions(kt) of Mongolia?
Offer a terse response. 5324.48. In the year 1965, what is the difference between the Emissions(kt) of Ireland and Emissions(kt) of United Kingdom?
Make the answer very short. -4.16e+05. In the year 1965, what is the difference between the Emissions(kt) of Mongolia and Emissions(kt) of United Kingdom?
Offer a terse response. -4.21e+05. In the year 1966, what is the difference between the Emissions(kt) in Faeroe Islands and Emissions(kt) in Ireland?
Ensure brevity in your answer.  -7418.34. In the year 1966, what is the difference between the Emissions(kt) in Faeroe Islands and Emissions(kt) in Mongolia?
Ensure brevity in your answer.  -1331.12. In the year 1966, what is the difference between the Emissions(kt) of Faeroe Islands and Emissions(kt) of United Kingdom?
Offer a very short reply. -4.04e+05. In the year 1966, what is the difference between the Emissions(kt) in Ireland and Emissions(kt) in Mongolia?
Your answer should be very brief. 6087.22. In the year 1966, what is the difference between the Emissions(kt) in Ireland and Emissions(kt) in United Kingdom?
Ensure brevity in your answer.  -3.96e+05. In the year 1966, what is the difference between the Emissions(kt) of Mongolia and Emissions(kt) of United Kingdom?
Offer a terse response. -4.02e+05. In the year 1967, what is the difference between the Emissions(kt) in Faeroe Islands and Emissions(kt) in Ireland?
Offer a terse response. -7645.69. In the year 1967, what is the difference between the Emissions(kt) in Faeroe Islands and Emissions(kt) in Mongolia?
Offer a terse response. -1433.8. In the year 1967, what is the difference between the Emissions(kt) in Faeroe Islands and Emissions(kt) in United Kingdom?
Your answer should be compact. -3.69e+05. In the year 1967, what is the difference between the Emissions(kt) of Ireland and Emissions(kt) of Mongolia?
Offer a terse response. 6211.9. In the year 1967, what is the difference between the Emissions(kt) in Ireland and Emissions(kt) in United Kingdom?
Your answer should be compact. -3.61e+05. In the year 1967, what is the difference between the Emissions(kt) in Mongolia and Emissions(kt) in United Kingdom?
Ensure brevity in your answer.  -3.67e+05. In the year 1968, what is the difference between the Emissions(kt) of Faeroe Islands and Emissions(kt) of Ireland?
Offer a terse response. -8866.81. In the year 1968, what is the difference between the Emissions(kt) of Faeroe Islands and Emissions(kt) of Mongolia?
Provide a short and direct response. -1697.82. In the year 1968, what is the difference between the Emissions(kt) of Faeroe Islands and Emissions(kt) of United Kingdom?
Offer a terse response. -3.71e+05. In the year 1968, what is the difference between the Emissions(kt) in Ireland and Emissions(kt) in Mongolia?
Give a very brief answer. 7168.98. In the year 1968, what is the difference between the Emissions(kt) of Ireland and Emissions(kt) of United Kingdom?
Ensure brevity in your answer.  -3.62e+05. In the year 1968, what is the difference between the Emissions(kt) of Mongolia and Emissions(kt) of United Kingdom?
Provide a succinct answer. -3.69e+05. In the year 1969, what is the difference between the Emissions(kt) in Faeroe Islands and Emissions(kt) in Ireland?
Your response must be concise. -8408.43. In the year 1969, what is the difference between the Emissions(kt) of Faeroe Islands and Emissions(kt) of Mongolia?
Your answer should be compact. -1873.84. In the year 1969, what is the difference between the Emissions(kt) of Faeroe Islands and Emissions(kt) of United Kingdom?
Give a very brief answer. -3.68e+05. In the year 1969, what is the difference between the Emissions(kt) of Ireland and Emissions(kt) of Mongolia?
Keep it short and to the point. 6534.59. In the year 1969, what is the difference between the Emissions(kt) of Ireland and Emissions(kt) of United Kingdom?
Your answer should be compact. -3.60e+05. In the year 1969, what is the difference between the Emissions(kt) in Mongolia and Emissions(kt) in United Kingdom?
Keep it short and to the point. -3.66e+05. In the year 1970, what is the difference between the Emissions(kt) in Faeroe Islands and Emissions(kt) in Ireland?
Your response must be concise. -8151.74. In the year 1970, what is the difference between the Emissions(kt) in Faeroe Islands and Emissions(kt) in Mongolia?
Your answer should be very brief. -1976.51. In the year 1970, what is the difference between the Emissions(kt) in Faeroe Islands and Emissions(kt) in United Kingdom?
Provide a succinct answer. -3.53e+05. In the year 1970, what is the difference between the Emissions(kt) in Ireland and Emissions(kt) in Mongolia?
Keep it short and to the point. 6175.23. In the year 1970, what is the difference between the Emissions(kt) of Ireland and Emissions(kt) of United Kingdom?
Keep it short and to the point. -3.45e+05. In the year 1970, what is the difference between the Emissions(kt) of Mongolia and Emissions(kt) of United Kingdom?
Make the answer very short. -3.51e+05. What is the ratio of the Emissions(kt) in Mongolia in 1963 to that in 1964?
Keep it short and to the point. 0.73. What is the ratio of the Emissions(kt) of United Kingdom in 1963 to that in 1964?
Offer a very short reply. 1.03. What is the ratio of the Emissions(kt) of Ireland in 1963 to that in 1965?
Your answer should be compact. 1.18. What is the ratio of the Emissions(kt) in Mongolia in 1963 to that in 1965?
Your answer should be compact. 0.77. What is the ratio of the Emissions(kt) of United Kingdom in 1963 to that in 1965?
Offer a very short reply. 1.04. What is the ratio of the Emissions(kt) in Faeroe Islands in 1963 to that in 1966?
Give a very brief answer. 1.5. What is the ratio of the Emissions(kt) of Ireland in 1963 to that in 1966?
Provide a short and direct response. 1.06. What is the ratio of the Emissions(kt) of Mongolia in 1963 to that in 1966?
Offer a very short reply. 0.77. What is the ratio of the Emissions(kt) in United Kingdom in 1963 to that in 1966?
Provide a short and direct response. 1.09. What is the ratio of the Emissions(kt) of Faeroe Islands in 1963 to that in 1967?
Your answer should be compact. 3. What is the ratio of the Emissions(kt) of Ireland in 1963 to that in 1967?
Your response must be concise. 1.03. What is the ratio of the Emissions(kt) in United Kingdom in 1963 to that in 1967?
Offer a terse response. 1.19. What is the ratio of the Emissions(kt) in Ireland in 1963 to that in 1968?
Ensure brevity in your answer.  0.89. What is the ratio of the Emissions(kt) of Mongolia in 1963 to that in 1968?
Provide a short and direct response. 0.6. What is the ratio of the Emissions(kt) of United Kingdom in 1963 to that in 1968?
Offer a very short reply. 1.19. What is the ratio of the Emissions(kt) of Ireland in 1963 to that in 1969?
Ensure brevity in your answer.  0.94. What is the ratio of the Emissions(kt) in Mongolia in 1963 to that in 1969?
Give a very brief answer. 0.55. What is the ratio of the Emissions(kt) of United Kingdom in 1963 to that in 1969?
Your answer should be compact. 1.19. What is the ratio of the Emissions(kt) of Ireland in 1963 to that in 1970?
Keep it short and to the point. 0.97. What is the ratio of the Emissions(kt) in Mongolia in 1963 to that in 1970?
Offer a terse response. 0.52. What is the ratio of the Emissions(kt) in United Kingdom in 1963 to that in 1970?
Your answer should be compact. 1.24. What is the ratio of the Emissions(kt) in Ireland in 1964 to that in 1965?
Your answer should be compact. 1.18. What is the ratio of the Emissions(kt) of Mongolia in 1964 to that in 1965?
Ensure brevity in your answer.  1.05. What is the ratio of the Emissions(kt) of United Kingdom in 1964 to that in 1965?
Your response must be concise. 1.01. What is the ratio of the Emissions(kt) of Faeroe Islands in 1964 to that in 1966?
Provide a short and direct response. 1. What is the ratio of the Emissions(kt) of Ireland in 1964 to that in 1966?
Your answer should be compact. 1.06. What is the ratio of the Emissions(kt) in Mongolia in 1964 to that in 1966?
Offer a terse response. 1.05. What is the ratio of the Emissions(kt) in United Kingdom in 1964 to that in 1966?
Your answer should be compact. 1.06. What is the ratio of the Emissions(kt) in Ireland in 1964 to that in 1967?
Ensure brevity in your answer.  1.03. What is the ratio of the Emissions(kt) in Mongolia in 1964 to that in 1967?
Your response must be concise. 0.98. What is the ratio of the Emissions(kt) in United Kingdom in 1964 to that in 1967?
Ensure brevity in your answer.  1.16. What is the ratio of the Emissions(kt) of Faeroe Islands in 1964 to that in 1968?
Keep it short and to the point. 2. What is the ratio of the Emissions(kt) of Ireland in 1964 to that in 1968?
Give a very brief answer. 0.89. What is the ratio of the Emissions(kt) in Mongolia in 1964 to that in 1968?
Your answer should be compact. 0.83. What is the ratio of the Emissions(kt) in United Kingdom in 1964 to that in 1968?
Offer a terse response. 1.15. What is the ratio of the Emissions(kt) of Faeroe Islands in 1964 to that in 1969?
Make the answer very short. 2. What is the ratio of the Emissions(kt) in Ireland in 1964 to that in 1969?
Offer a very short reply. 0.94. What is the ratio of the Emissions(kt) in Mongolia in 1964 to that in 1969?
Offer a terse response. 0.75. What is the ratio of the Emissions(kt) in United Kingdom in 1964 to that in 1969?
Ensure brevity in your answer.  1.16. What is the ratio of the Emissions(kt) in Ireland in 1964 to that in 1970?
Ensure brevity in your answer.  0.97. What is the ratio of the Emissions(kt) in Mongolia in 1964 to that in 1970?
Your answer should be very brief. 0.71. What is the ratio of the Emissions(kt) of United Kingdom in 1964 to that in 1970?
Keep it short and to the point. 1.21. What is the ratio of the Emissions(kt) of Faeroe Islands in 1965 to that in 1966?
Your answer should be very brief. 1. What is the ratio of the Emissions(kt) of Ireland in 1965 to that in 1966?
Keep it short and to the point. 0.9. What is the ratio of the Emissions(kt) of Mongolia in 1965 to that in 1966?
Provide a succinct answer. 1. What is the ratio of the Emissions(kt) of United Kingdom in 1965 to that in 1966?
Make the answer very short. 1.05. What is the ratio of the Emissions(kt) in Faeroe Islands in 1965 to that in 1967?
Provide a short and direct response. 2. What is the ratio of the Emissions(kt) of Ireland in 1965 to that in 1967?
Offer a very short reply. 0.87. What is the ratio of the Emissions(kt) in Mongolia in 1965 to that in 1967?
Your answer should be compact. 0.93. What is the ratio of the Emissions(kt) of United Kingdom in 1965 to that in 1967?
Give a very brief answer. 1.15. What is the ratio of the Emissions(kt) of Faeroe Islands in 1965 to that in 1968?
Keep it short and to the point. 2. What is the ratio of the Emissions(kt) of Ireland in 1965 to that in 1968?
Your answer should be very brief. 0.75. What is the ratio of the Emissions(kt) in Mongolia in 1965 to that in 1968?
Offer a terse response. 0.79. What is the ratio of the Emissions(kt) of United Kingdom in 1965 to that in 1968?
Keep it short and to the point. 1.14. What is the ratio of the Emissions(kt) of Faeroe Islands in 1965 to that in 1969?
Offer a terse response. 2. What is the ratio of the Emissions(kt) in Ireland in 1965 to that in 1969?
Provide a short and direct response. 0.79. What is the ratio of the Emissions(kt) in Mongolia in 1965 to that in 1969?
Your answer should be very brief. 0.71. What is the ratio of the Emissions(kt) in United Kingdom in 1965 to that in 1969?
Your answer should be very brief. 1.15. What is the ratio of the Emissions(kt) in Faeroe Islands in 1965 to that in 1970?
Provide a short and direct response. 2. What is the ratio of the Emissions(kt) of Ireland in 1965 to that in 1970?
Provide a succinct answer. 0.82. What is the ratio of the Emissions(kt) of Mongolia in 1965 to that in 1970?
Your answer should be compact. 0.68. What is the ratio of the Emissions(kt) in United Kingdom in 1965 to that in 1970?
Your answer should be compact. 1.2. What is the ratio of the Emissions(kt) in Ireland in 1966 to that in 1967?
Offer a terse response. 0.97. What is the ratio of the Emissions(kt) in Mongolia in 1966 to that in 1967?
Provide a short and direct response. 0.93. What is the ratio of the Emissions(kt) of United Kingdom in 1966 to that in 1967?
Offer a very short reply. 1.09. What is the ratio of the Emissions(kt) of Ireland in 1966 to that in 1968?
Offer a very short reply. 0.84. What is the ratio of the Emissions(kt) of Mongolia in 1966 to that in 1968?
Provide a short and direct response. 0.79. What is the ratio of the Emissions(kt) of United Kingdom in 1966 to that in 1968?
Make the answer very short. 1.09. What is the ratio of the Emissions(kt) in Faeroe Islands in 1966 to that in 1969?
Offer a very short reply. 2. What is the ratio of the Emissions(kt) in Ireland in 1966 to that in 1969?
Your answer should be very brief. 0.88. What is the ratio of the Emissions(kt) of Mongolia in 1966 to that in 1969?
Keep it short and to the point. 0.71. What is the ratio of the Emissions(kt) in United Kingdom in 1966 to that in 1969?
Make the answer very short. 1.1. What is the ratio of the Emissions(kt) of Faeroe Islands in 1966 to that in 1970?
Offer a terse response. 2. What is the ratio of the Emissions(kt) in Ireland in 1966 to that in 1970?
Your answer should be compact. 0.91. What is the ratio of the Emissions(kt) in Mongolia in 1966 to that in 1970?
Make the answer very short. 0.68. What is the ratio of the Emissions(kt) of United Kingdom in 1966 to that in 1970?
Keep it short and to the point. 1.14. What is the ratio of the Emissions(kt) of Ireland in 1967 to that in 1968?
Your answer should be compact. 0.86. What is the ratio of the Emissions(kt) of Mongolia in 1967 to that in 1968?
Offer a very short reply. 0.84. What is the ratio of the Emissions(kt) in United Kingdom in 1967 to that in 1968?
Provide a succinct answer. 1. What is the ratio of the Emissions(kt) of Ireland in 1967 to that in 1969?
Offer a terse response. 0.91. What is the ratio of the Emissions(kt) of Mongolia in 1967 to that in 1969?
Offer a very short reply. 0.77. What is the ratio of the Emissions(kt) of United Kingdom in 1967 to that in 1969?
Your answer should be very brief. 1. What is the ratio of the Emissions(kt) of Faeroe Islands in 1967 to that in 1970?
Provide a short and direct response. 1. What is the ratio of the Emissions(kt) in Ireland in 1967 to that in 1970?
Give a very brief answer. 0.94. What is the ratio of the Emissions(kt) in Mongolia in 1967 to that in 1970?
Ensure brevity in your answer.  0.73. What is the ratio of the Emissions(kt) in United Kingdom in 1967 to that in 1970?
Offer a terse response. 1.04. What is the ratio of the Emissions(kt) in Ireland in 1968 to that in 1969?
Make the answer very short. 1.05. What is the ratio of the Emissions(kt) of Mongolia in 1968 to that in 1969?
Ensure brevity in your answer.  0.91. What is the ratio of the Emissions(kt) in United Kingdom in 1968 to that in 1969?
Your response must be concise. 1.01. What is the ratio of the Emissions(kt) in Faeroe Islands in 1968 to that in 1970?
Provide a succinct answer. 1. What is the ratio of the Emissions(kt) of Ireland in 1968 to that in 1970?
Offer a terse response. 1.09. What is the ratio of the Emissions(kt) in Mongolia in 1968 to that in 1970?
Offer a very short reply. 0.86. What is the ratio of the Emissions(kt) of United Kingdom in 1968 to that in 1970?
Give a very brief answer. 1.05. What is the ratio of the Emissions(kt) in Faeroe Islands in 1969 to that in 1970?
Give a very brief answer. 1. What is the ratio of the Emissions(kt) of Ireland in 1969 to that in 1970?
Offer a terse response. 1.03. What is the ratio of the Emissions(kt) in Mongolia in 1969 to that in 1970?
Provide a short and direct response. 0.95. What is the ratio of the Emissions(kt) of United Kingdom in 1969 to that in 1970?
Provide a short and direct response. 1.04. What is the difference between the highest and the second highest Emissions(kt) in Faeroe Islands?
Your answer should be very brief. 3.67. What is the difference between the highest and the second highest Emissions(kt) of Ireland?
Make the answer very short. 458.38. What is the difference between the highest and the second highest Emissions(kt) of Mongolia?
Make the answer very short. 102.68. What is the difference between the highest and the second highest Emissions(kt) in United Kingdom?
Your answer should be very brief. 1.31e+04. What is the difference between the highest and the lowest Emissions(kt) of Faeroe Islands?
Ensure brevity in your answer.  7.33. What is the difference between the highest and the lowest Emissions(kt) of Ireland?
Give a very brief answer. 2203.87. What is the difference between the highest and the lowest Emissions(kt) of Mongolia?
Your answer should be very brief. 953.42. What is the difference between the highest and the lowest Emissions(kt) in United Kingdom?
Ensure brevity in your answer.  8.65e+04. 